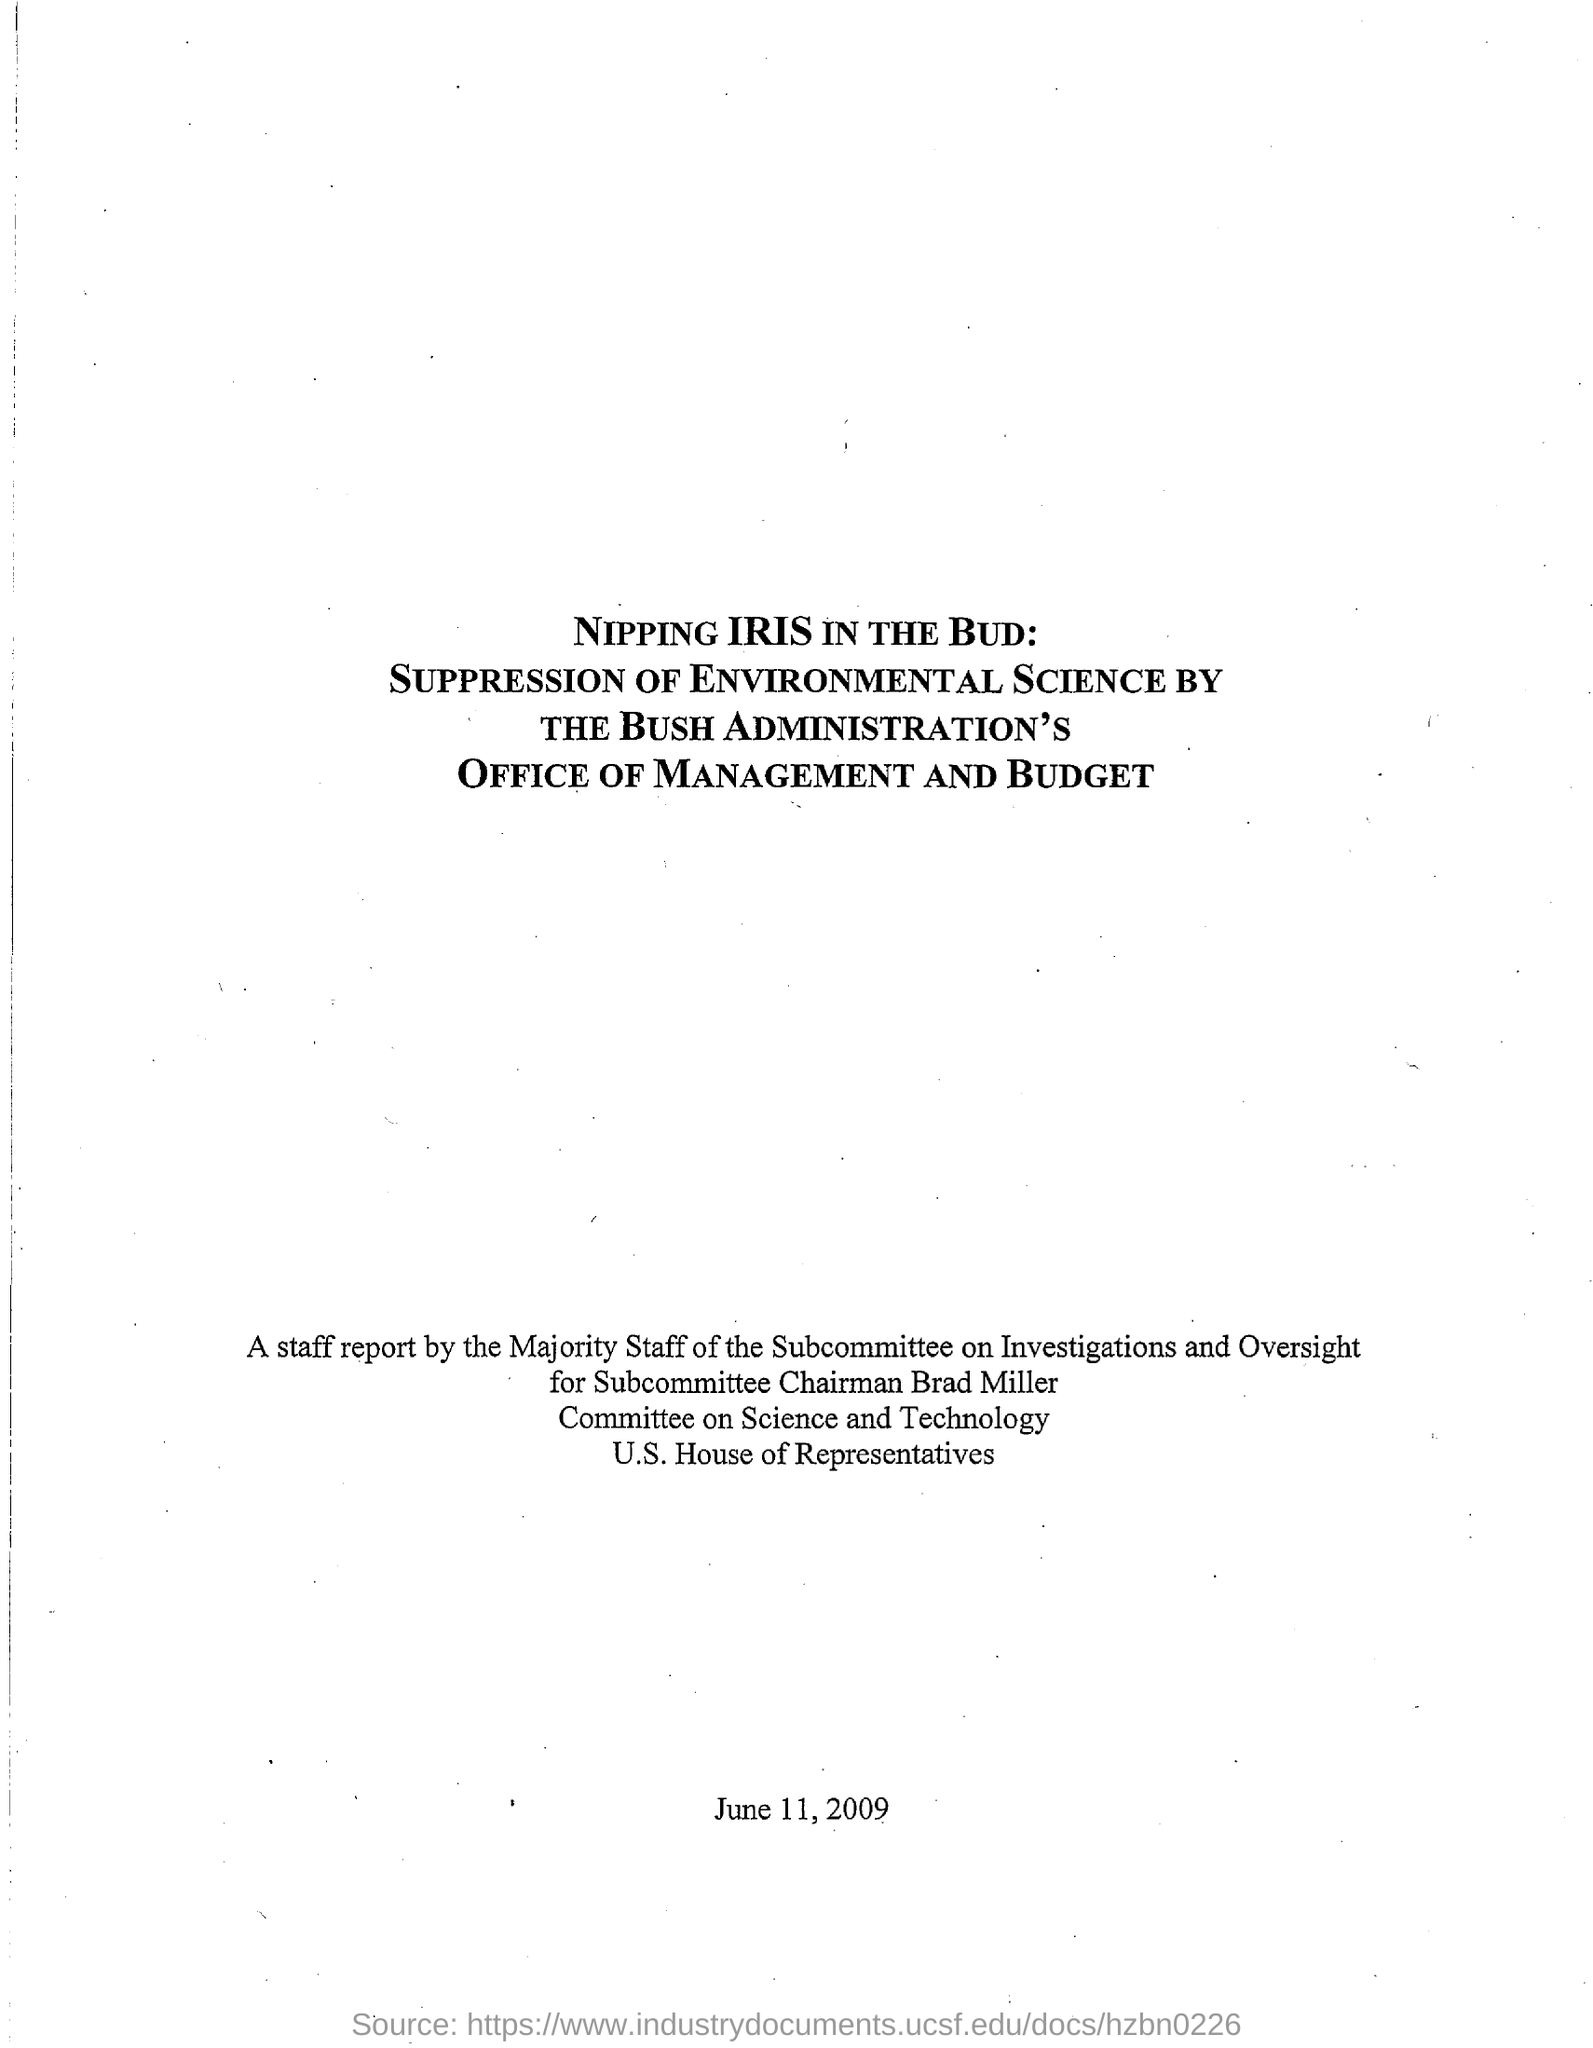List a handful of essential elements in this visual. The document states that the date mentioned is June 11, 2009. 